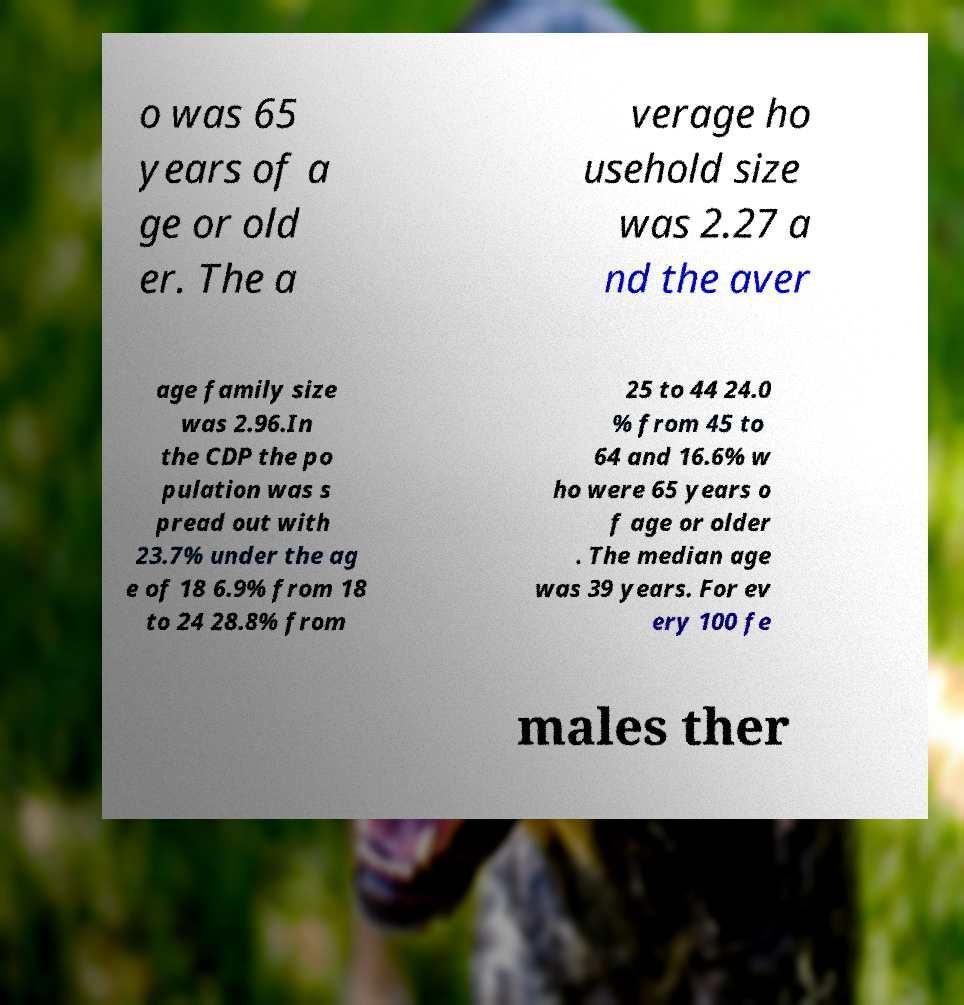Could you assist in decoding the text presented in this image and type it out clearly? o was 65 years of a ge or old er. The a verage ho usehold size was 2.27 a nd the aver age family size was 2.96.In the CDP the po pulation was s pread out with 23.7% under the ag e of 18 6.9% from 18 to 24 28.8% from 25 to 44 24.0 % from 45 to 64 and 16.6% w ho were 65 years o f age or older . The median age was 39 years. For ev ery 100 fe males ther 